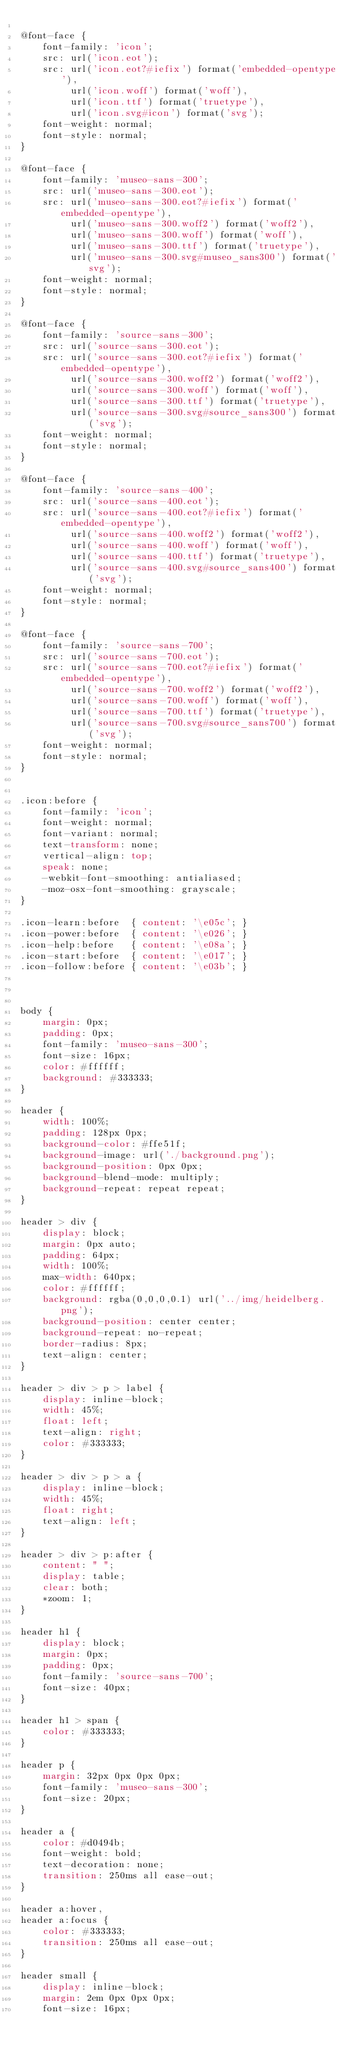Convert code to text. <code><loc_0><loc_0><loc_500><loc_500><_CSS_>
@font-face {
	font-family: 'icon';
	src: url('icon.eot');
	src: url('icon.eot?#iefix') format('embedded-opentype'),
		 url('icon.woff') format('woff'),
		 url('icon.ttf') format('truetype'),
		 url('icon.svg#icon') format('svg');
	font-weight: normal;
	font-style: normal;
}

@font-face {
	font-family: 'museo-sans-300';
	src: url('museo-sans-300.eot');
	src: url('museo-sans-300.eot?#iefix') format('embedded-opentype'),
		 url('museo-sans-300.woff2') format('woff2'),
		 url('museo-sans-300.woff') format('woff'),
		 url('museo-sans-300.ttf') format('truetype'),
		 url('museo-sans-300.svg#museo_sans300') format('svg');
	font-weight: normal;
	font-style: normal;
}

@font-face {
	font-family: 'source-sans-300';
	src: url('source-sans-300.eot');
	src: url('source-sans-300.eot?#iefix') format('embedded-opentype'),
		 url('source-sans-300.woff2') format('woff2'),
		 url('source-sans-300.woff') format('woff'),
		 url('source-sans-300.ttf') format('truetype'),
		 url('source-sans-300.svg#source_sans300') format('svg');
	font-weight: normal;
	font-style: normal;
}

@font-face {
	font-family: 'source-sans-400';
	src: url('source-sans-400.eot');
	src: url('source-sans-400.eot?#iefix') format('embedded-opentype'),
		 url('source-sans-400.woff2') format('woff2'),
		 url('source-sans-400.woff') format('woff'),
		 url('source-sans-400.ttf') format('truetype'),
		 url('source-sans-400.svg#source_sans400') format('svg');
	font-weight: normal;
	font-style: normal;
}

@font-face {
	font-family: 'source-sans-700';
	src: url('source-sans-700.eot');
	src: url('source-sans-700.eot?#iefix') format('embedded-opentype'),
		 url('source-sans-700.woff2') format('woff2'),
		 url('source-sans-700.woff') format('woff'),
		 url('source-sans-700.ttf') format('truetype'),
		 url('source-sans-700.svg#source_sans700') format('svg');
	font-weight: normal;
	font-style: normal;
}


.icon:before {
	font-family: 'icon';
	font-weight: normal;
	font-variant: normal;
	text-transform: none;
	vertical-align: top;
	speak: none;
	-webkit-font-smoothing: antialiased;
	-moz-osx-font-smoothing: grayscale;
}

.icon-learn:before  { content: '\e05c'; }
.icon-power:before  { content: '\e026'; }
.icon-help:before   { content: '\e08a'; }
.icon-start:before  { content: '\e017'; }
.icon-follow:before { content: '\e03b'; }



body {
	margin: 0px;
	padding: 0px;
	font-family: 'museo-sans-300';
	font-size: 16px;
	color: #ffffff;
	background: #333333;
}

header {
	width: 100%;
	padding: 128px 0px;
	background-color: #ffe51f;
	background-image: url('./background.png');
	background-position: 0px 0px;
	background-blend-mode: multiply;
	background-repeat: repeat repeat;
}

header > div {
	display: block;
	margin: 0px auto;
	padding: 64px;
	width: 100%;
	max-width: 640px;
	color: #ffffff;
	background: rgba(0,0,0,0.1) url('../img/heidelberg.png');
	background-position: center center;
	background-repeat: no-repeat;
	border-radius: 8px;
	text-align: center;
}

header > div > p > label {
	display: inline-block;
	width: 45%;
	float: left;
	text-align: right;
	color: #333333;
}

header > div > p > a {
	display: inline-block;
	width: 45%;
	float: right;
	text-align: left;
}

header > div > p:after {
	content: " ";
	display: table;
	clear: both;
	*zoom: 1;
}

header h1 {
	display: block;
	margin: 0px;
	padding: 0px;
	font-family: 'source-sans-700';
	font-size: 40px;
}

header h1 > span {
	color: #333333;
}

header p {
	margin: 32px 0px 0px 0px;
	font-family: 'museo-sans-300';
	font-size: 20px;
}

header a {
	color: #d0494b;
	font-weight: bold;
	text-decoration: none;
	transition: 250ms all ease-out;
}

header a:hover,
header a:focus {
	color: #333333;
	transition: 250ms all ease-out;
}

header small {
	display: inline-block;
	margin: 2em 0px 0px 0px;
	font-size: 16px;</code> 